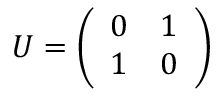<formula> <loc_0><loc_0><loc_500><loc_500>U = { \left ( \begin{array} { l l } { 0 } & { 1 } \\ { 1 } & { 0 } \end{array} \right ) }</formula> 